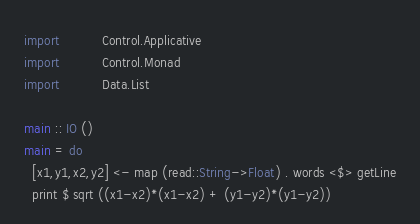<code> <loc_0><loc_0><loc_500><loc_500><_Haskell_>import           Control.Applicative
import           Control.Monad
import           Data.List

main :: IO ()
main = do
  [x1,y1,x2,y2] <- map (read::String->Float) . words <$> getLine
  print $ sqrt ((x1-x2)*(x1-x2) + (y1-y2)*(y1-y2))

</code> 